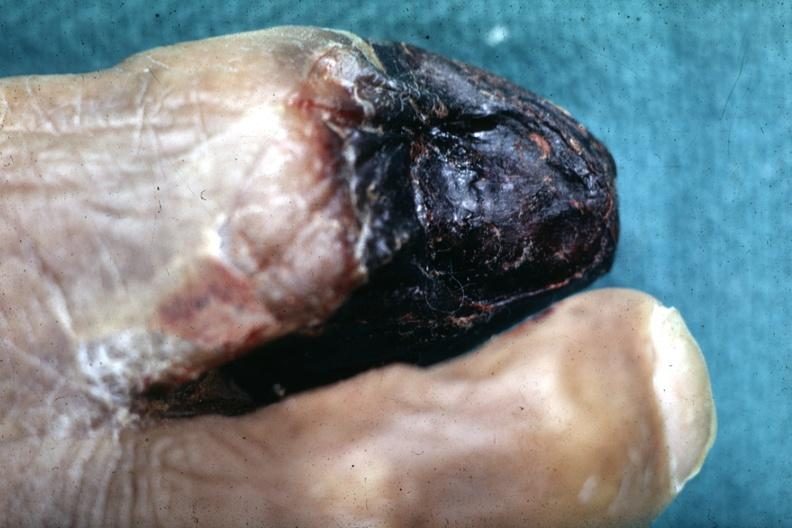s feet present?
Answer the question using a single word or phrase. Yes 